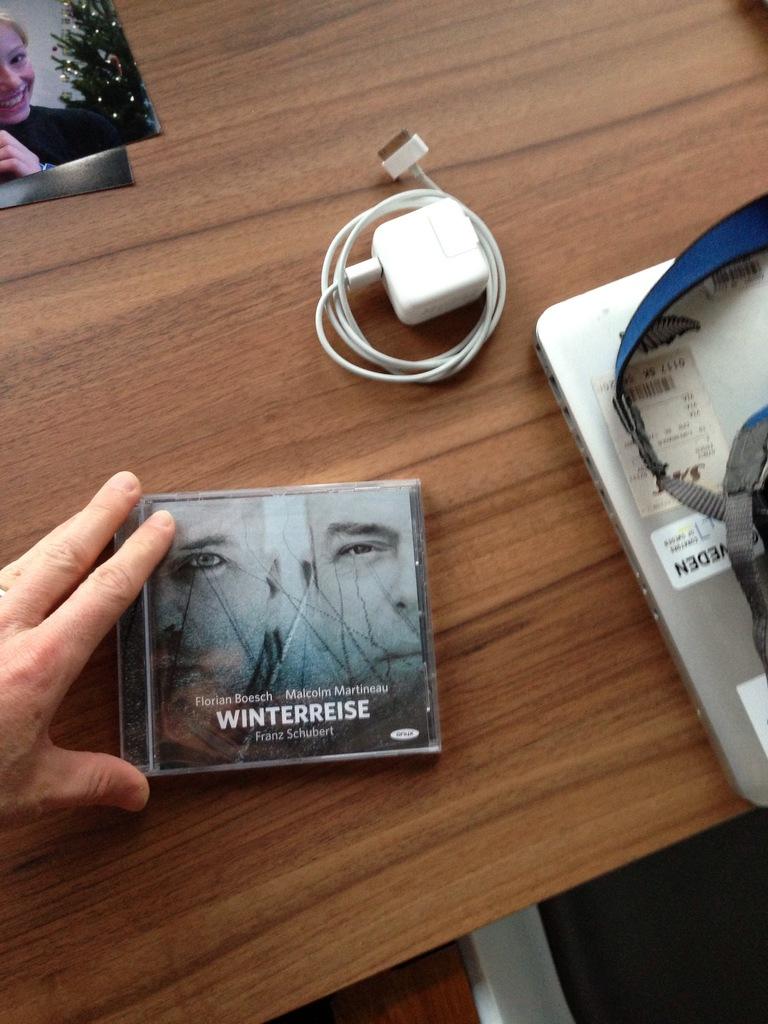What is this dvd's name?
Ensure brevity in your answer.  Winterreise. If this is dvd player?
Make the answer very short. No. 